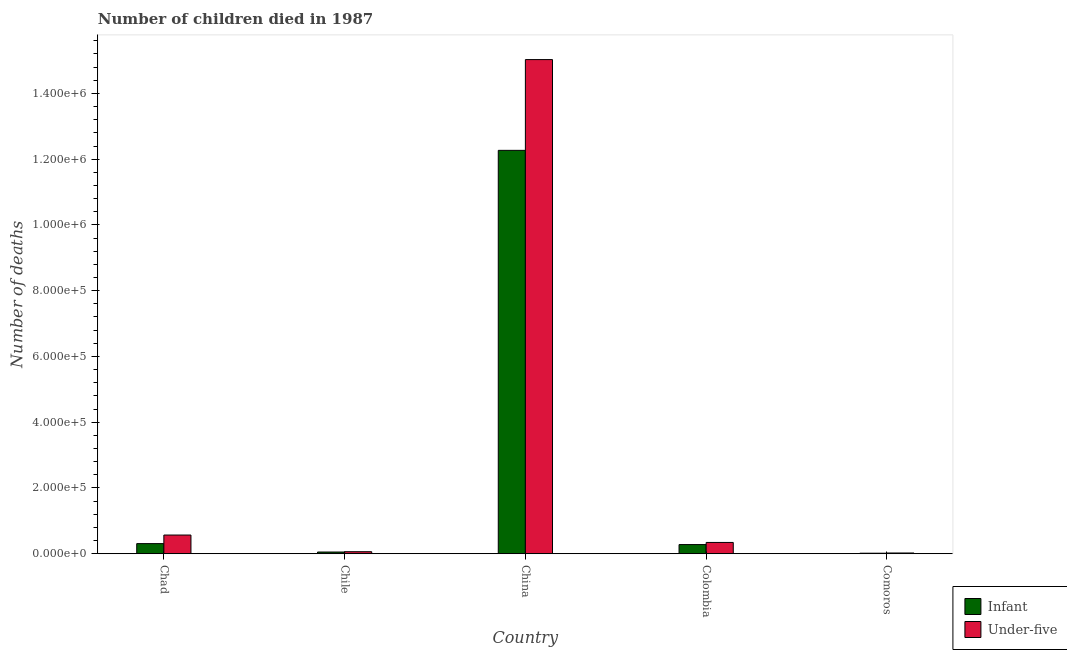How many groups of bars are there?
Your response must be concise. 5. How many bars are there on the 2nd tick from the right?
Make the answer very short. 2. What is the number of infant deaths in China?
Make the answer very short. 1.23e+06. Across all countries, what is the maximum number of under-five deaths?
Ensure brevity in your answer.  1.50e+06. Across all countries, what is the minimum number of under-five deaths?
Your response must be concise. 2249. In which country was the number of under-five deaths minimum?
Ensure brevity in your answer.  Comoros. What is the total number of infant deaths in the graph?
Offer a terse response. 1.29e+06. What is the difference between the number of under-five deaths in China and that in Comoros?
Offer a terse response. 1.50e+06. What is the difference between the number of under-five deaths in Chad and the number of infant deaths in Colombia?
Provide a succinct answer. 2.90e+04. What is the average number of infant deaths per country?
Offer a very short reply. 2.58e+05. What is the difference between the number of under-five deaths and number of infant deaths in Chad?
Your answer should be compact. 2.61e+04. What is the ratio of the number of infant deaths in Chile to that in Colombia?
Give a very brief answer. 0.19. Is the number of under-five deaths in Chad less than that in Comoros?
Provide a succinct answer. No. What is the difference between the highest and the second highest number of infant deaths?
Provide a short and direct response. 1.20e+06. What is the difference between the highest and the lowest number of infant deaths?
Your response must be concise. 1.23e+06. What does the 1st bar from the left in Chad represents?
Give a very brief answer. Infant. What does the 1st bar from the right in Chad represents?
Your answer should be compact. Under-five. Are all the bars in the graph horizontal?
Offer a very short reply. No. What is the difference between two consecutive major ticks on the Y-axis?
Your answer should be compact. 2.00e+05. Are the values on the major ticks of Y-axis written in scientific E-notation?
Your response must be concise. Yes. How many legend labels are there?
Provide a succinct answer. 2. What is the title of the graph?
Provide a succinct answer. Number of children died in 1987. What is the label or title of the Y-axis?
Provide a succinct answer. Number of deaths. What is the Number of deaths of Infant in Chad?
Your response must be concise. 3.08e+04. What is the Number of deaths in Under-five in Chad?
Your answer should be very brief. 5.69e+04. What is the Number of deaths in Infant in Chile?
Keep it short and to the point. 5216. What is the Number of deaths of Under-five in Chile?
Provide a succinct answer. 6148. What is the Number of deaths in Infant in China?
Provide a short and direct response. 1.23e+06. What is the Number of deaths of Under-five in China?
Offer a terse response. 1.50e+06. What is the Number of deaths of Infant in Colombia?
Provide a succinct answer. 2.79e+04. What is the Number of deaths in Under-five in Colombia?
Offer a very short reply. 3.43e+04. What is the Number of deaths in Infant in Comoros?
Your response must be concise. 1580. What is the Number of deaths of Under-five in Comoros?
Provide a short and direct response. 2249. Across all countries, what is the maximum Number of deaths in Infant?
Offer a very short reply. 1.23e+06. Across all countries, what is the maximum Number of deaths in Under-five?
Provide a succinct answer. 1.50e+06. Across all countries, what is the minimum Number of deaths in Infant?
Ensure brevity in your answer.  1580. Across all countries, what is the minimum Number of deaths in Under-five?
Make the answer very short. 2249. What is the total Number of deaths in Infant in the graph?
Offer a terse response. 1.29e+06. What is the total Number of deaths of Under-five in the graph?
Ensure brevity in your answer.  1.60e+06. What is the difference between the Number of deaths of Infant in Chad and that in Chile?
Make the answer very short. 2.56e+04. What is the difference between the Number of deaths in Under-five in Chad and that in Chile?
Provide a succinct answer. 5.07e+04. What is the difference between the Number of deaths of Infant in Chad and that in China?
Give a very brief answer. -1.20e+06. What is the difference between the Number of deaths in Under-five in Chad and that in China?
Offer a terse response. -1.45e+06. What is the difference between the Number of deaths of Infant in Chad and that in Colombia?
Keep it short and to the point. 2915. What is the difference between the Number of deaths of Under-five in Chad and that in Colombia?
Provide a short and direct response. 2.26e+04. What is the difference between the Number of deaths of Infant in Chad and that in Comoros?
Provide a succinct answer. 2.92e+04. What is the difference between the Number of deaths in Under-five in Chad and that in Comoros?
Provide a short and direct response. 5.46e+04. What is the difference between the Number of deaths in Infant in Chile and that in China?
Your answer should be compact. -1.22e+06. What is the difference between the Number of deaths in Under-five in Chile and that in China?
Keep it short and to the point. -1.50e+06. What is the difference between the Number of deaths in Infant in Chile and that in Colombia?
Provide a short and direct response. -2.26e+04. What is the difference between the Number of deaths in Under-five in Chile and that in Colombia?
Keep it short and to the point. -2.82e+04. What is the difference between the Number of deaths in Infant in Chile and that in Comoros?
Your answer should be compact. 3636. What is the difference between the Number of deaths of Under-five in Chile and that in Comoros?
Your answer should be very brief. 3899. What is the difference between the Number of deaths of Infant in China and that in Colombia?
Offer a very short reply. 1.20e+06. What is the difference between the Number of deaths of Under-five in China and that in Colombia?
Provide a short and direct response. 1.47e+06. What is the difference between the Number of deaths in Infant in China and that in Comoros?
Offer a terse response. 1.23e+06. What is the difference between the Number of deaths of Under-five in China and that in Comoros?
Your answer should be compact. 1.50e+06. What is the difference between the Number of deaths of Infant in Colombia and that in Comoros?
Your answer should be very brief. 2.63e+04. What is the difference between the Number of deaths of Under-five in Colombia and that in Comoros?
Make the answer very short. 3.21e+04. What is the difference between the Number of deaths of Infant in Chad and the Number of deaths of Under-five in Chile?
Your answer should be compact. 2.46e+04. What is the difference between the Number of deaths in Infant in Chad and the Number of deaths in Under-five in China?
Provide a short and direct response. -1.47e+06. What is the difference between the Number of deaths of Infant in Chad and the Number of deaths of Under-five in Colombia?
Make the answer very short. -3536. What is the difference between the Number of deaths of Infant in Chad and the Number of deaths of Under-five in Comoros?
Make the answer very short. 2.85e+04. What is the difference between the Number of deaths in Infant in Chile and the Number of deaths in Under-five in China?
Your answer should be compact. -1.50e+06. What is the difference between the Number of deaths of Infant in Chile and the Number of deaths of Under-five in Colombia?
Offer a terse response. -2.91e+04. What is the difference between the Number of deaths in Infant in Chile and the Number of deaths in Under-five in Comoros?
Ensure brevity in your answer.  2967. What is the difference between the Number of deaths of Infant in China and the Number of deaths of Under-five in Colombia?
Keep it short and to the point. 1.19e+06. What is the difference between the Number of deaths in Infant in China and the Number of deaths in Under-five in Comoros?
Your answer should be compact. 1.22e+06. What is the difference between the Number of deaths in Infant in Colombia and the Number of deaths in Under-five in Comoros?
Make the answer very short. 2.56e+04. What is the average Number of deaths in Infant per country?
Make the answer very short. 2.58e+05. What is the average Number of deaths of Under-five per country?
Keep it short and to the point. 3.20e+05. What is the difference between the Number of deaths of Infant and Number of deaths of Under-five in Chad?
Your answer should be very brief. -2.61e+04. What is the difference between the Number of deaths in Infant and Number of deaths in Under-five in Chile?
Provide a succinct answer. -932. What is the difference between the Number of deaths in Infant and Number of deaths in Under-five in China?
Provide a succinct answer. -2.76e+05. What is the difference between the Number of deaths of Infant and Number of deaths of Under-five in Colombia?
Offer a very short reply. -6451. What is the difference between the Number of deaths in Infant and Number of deaths in Under-five in Comoros?
Offer a very short reply. -669. What is the ratio of the Number of deaths of Infant in Chad to that in Chile?
Ensure brevity in your answer.  5.9. What is the ratio of the Number of deaths of Under-five in Chad to that in Chile?
Give a very brief answer. 9.25. What is the ratio of the Number of deaths in Infant in Chad to that in China?
Offer a very short reply. 0.03. What is the ratio of the Number of deaths in Under-five in Chad to that in China?
Your answer should be very brief. 0.04. What is the ratio of the Number of deaths in Infant in Chad to that in Colombia?
Your response must be concise. 1.1. What is the ratio of the Number of deaths of Under-five in Chad to that in Colombia?
Your response must be concise. 1.66. What is the ratio of the Number of deaths of Infant in Chad to that in Comoros?
Provide a succinct answer. 19.48. What is the ratio of the Number of deaths in Under-five in Chad to that in Comoros?
Ensure brevity in your answer.  25.29. What is the ratio of the Number of deaths in Infant in Chile to that in China?
Provide a succinct answer. 0. What is the ratio of the Number of deaths in Under-five in Chile to that in China?
Your response must be concise. 0. What is the ratio of the Number of deaths of Infant in Chile to that in Colombia?
Provide a short and direct response. 0.19. What is the ratio of the Number of deaths of Under-five in Chile to that in Colombia?
Ensure brevity in your answer.  0.18. What is the ratio of the Number of deaths in Infant in Chile to that in Comoros?
Give a very brief answer. 3.3. What is the ratio of the Number of deaths of Under-five in Chile to that in Comoros?
Make the answer very short. 2.73. What is the ratio of the Number of deaths in Infant in China to that in Colombia?
Ensure brevity in your answer.  44.03. What is the ratio of the Number of deaths of Under-five in China to that in Colombia?
Offer a very short reply. 43.8. What is the ratio of the Number of deaths of Infant in China to that in Comoros?
Offer a terse response. 776.49. What is the ratio of the Number of deaths of Under-five in China to that in Comoros?
Keep it short and to the point. 668.26. What is the ratio of the Number of deaths in Infant in Colombia to that in Comoros?
Your response must be concise. 17.64. What is the ratio of the Number of deaths in Under-five in Colombia to that in Comoros?
Offer a terse response. 15.26. What is the difference between the highest and the second highest Number of deaths in Infant?
Your answer should be compact. 1.20e+06. What is the difference between the highest and the second highest Number of deaths of Under-five?
Give a very brief answer. 1.45e+06. What is the difference between the highest and the lowest Number of deaths of Infant?
Your answer should be very brief. 1.23e+06. What is the difference between the highest and the lowest Number of deaths in Under-five?
Offer a terse response. 1.50e+06. 